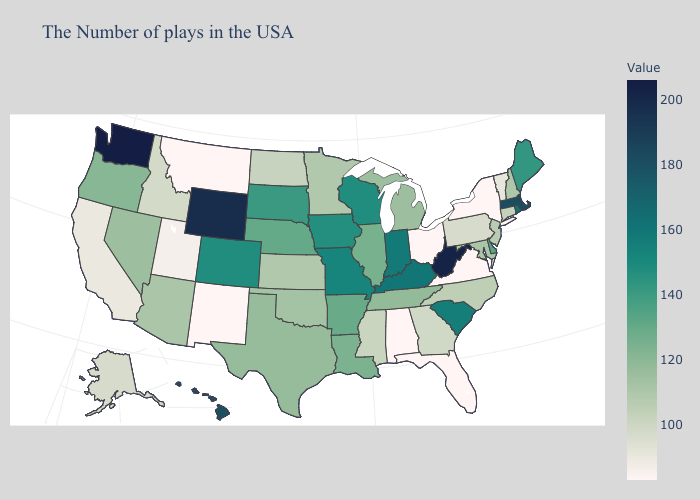Which states have the lowest value in the West?
Concise answer only. New Mexico, Montana. Among the states that border Florida , does Alabama have the highest value?
Quick response, please. No. Does New Hampshire have the lowest value in the USA?
Write a very short answer. No. Does Utah have the highest value in the West?
Keep it brief. No. Is the legend a continuous bar?
Give a very brief answer. Yes. Which states have the highest value in the USA?
Write a very short answer. Washington. Does Connecticut have the highest value in the Northeast?
Concise answer only. No. 